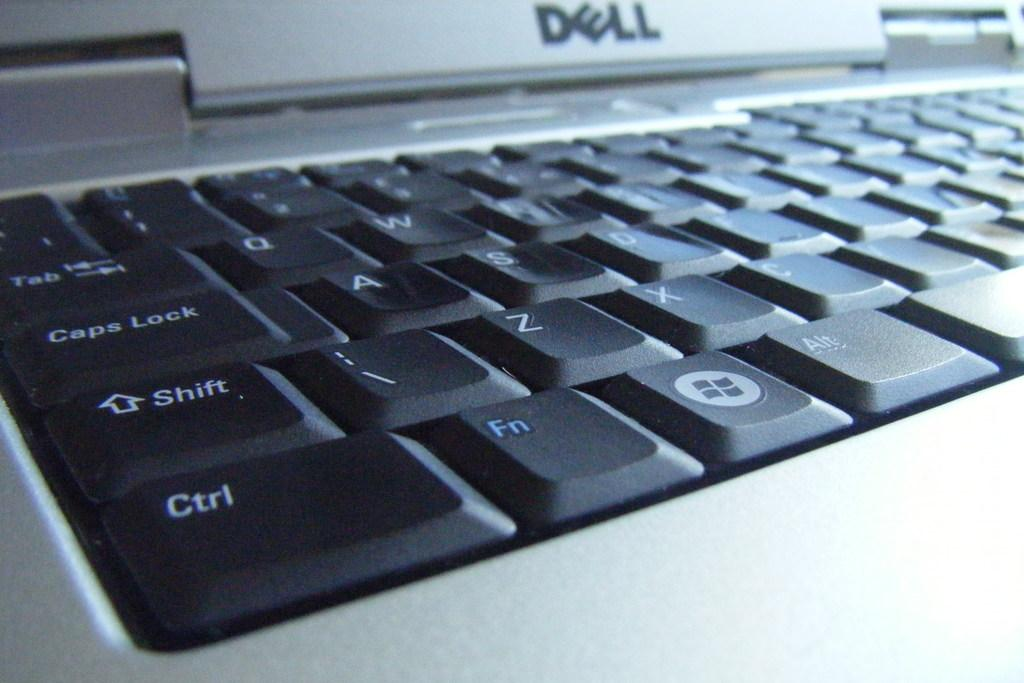<image>
Write a terse but informative summary of the picture. a close up shot of a dell laptop keyboard 